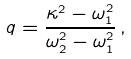<formula> <loc_0><loc_0><loc_500><loc_500>q = \frac { \kappa ^ { 2 } - \omega _ { 1 } ^ { 2 } } { \omega _ { 2 } ^ { 2 } - \omega _ { 1 } ^ { 2 } } \, ,</formula> 